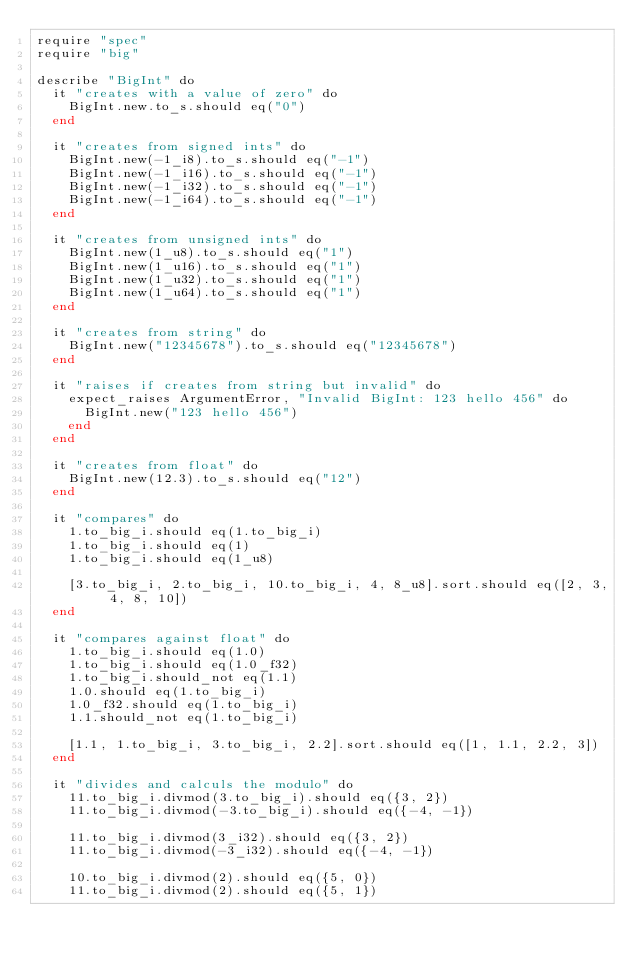<code> <loc_0><loc_0><loc_500><loc_500><_Crystal_>require "spec"
require "big"

describe "BigInt" do
  it "creates with a value of zero" do
    BigInt.new.to_s.should eq("0")
  end

  it "creates from signed ints" do
    BigInt.new(-1_i8).to_s.should eq("-1")
    BigInt.new(-1_i16).to_s.should eq("-1")
    BigInt.new(-1_i32).to_s.should eq("-1")
    BigInt.new(-1_i64).to_s.should eq("-1")
  end

  it "creates from unsigned ints" do
    BigInt.new(1_u8).to_s.should eq("1")
    BigInt.new(1_u16).to_s.should eq("1")
    BigInt.new(1_u32).to_s.should eq("1")
    BigInt.new(1_u64).to_s.should eq("1")
  end

  it "creates from string" do
    BigInt.new("12345678").to_s.should eq("12345678")
  end

  it "raises if creates from string but invalid" do
    expect_raises ArgumentError, "Invalid BigInt: 123 hello 456" do
      BigInt.new("123 hello 456")
    end
  end

  it "creates from float" do
    BigInt.new(12.3).to_s.should eq("12")
  end

  it "compares" do
    1.to_big_i.should eq(1.to_big_i)
    1.to_big_i.should eq(1)
    1.to_big_i.should eq(1_u8)

    [3.to_big_i, 2.to_big_i, 10.to_big_i, 4, 8_u8].sort.should eq([2, 3, 4, 8, 10])
  end

  it "compares against float" do
    1.to_big_i.should eq(1.0)
    1.to_big_i.should eq(1.0_f32)
    1.to_big_i.should_not eq(1.1)
    1.0.should eq(1.to_big_i)
    1.0_f32.should eq(1.to_big_i)
    1.1.should_not eq(1.to_big_i)

    [1.1, 1.to_big_i, 3.to_big_i, 2.2].sort.should eq([1, 1.1, 2.2, 3])
  end

  it "divides and calculs the modulo" do
    11.to_big_i.divmod(3.to_big_i).should eq({3, 2})
    11.to_big_i.divmod(-3.to_big_i).should eq({-4, -1})

    11.to_big_i.divmod(3_i32).should eq({3, 2})
    11.to_big_i.divmod(-3_i32).should eq({-4, -1})

    10.to_big_i.divmod(2).should eq({5, 0})
    11.to_big_i.divmod(2).should eq({5, 1})
</code> 